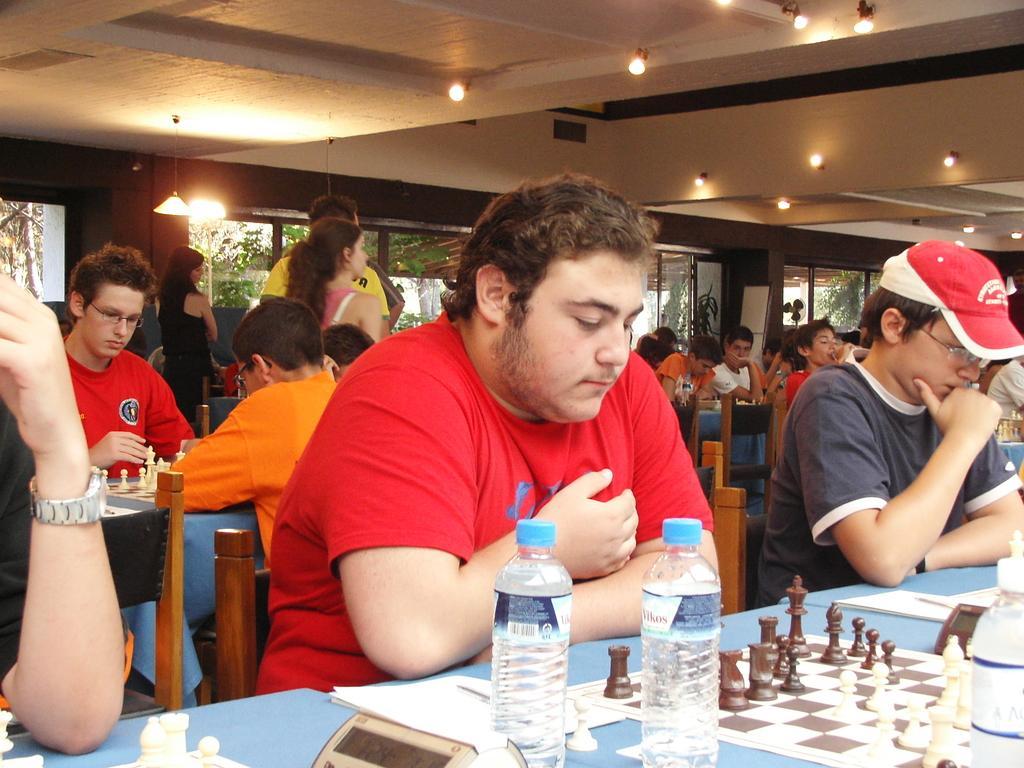Please provide a concise description of this image. There are many people sitting on the chair. There are two persons standing. In front there is a table. On the table there are two bottles, chess board, coins and a calculator. In front of the table there is a man with red t-shirt is sitting. To the right side there is a boy with grey t-shirt and a cap on his head is sitting. On the top there are some lights. In the background there are windows. 